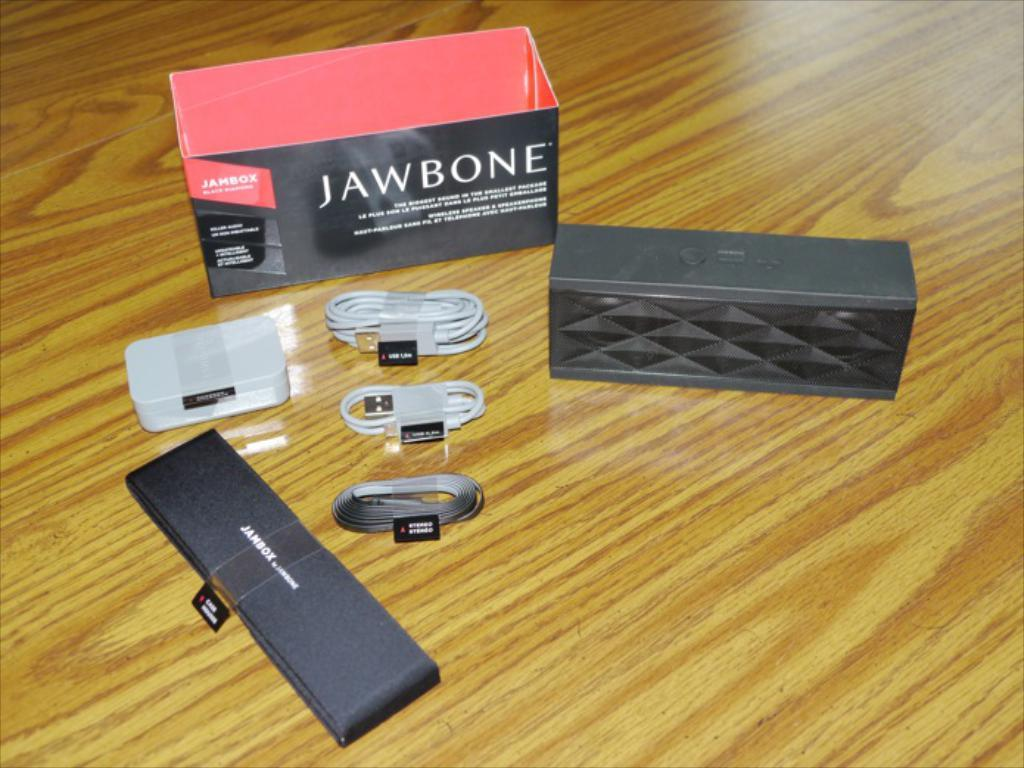Provide a one-sentence caption for the provided image. A box that says "jawbone" sits with some cables and other smaller boxes. 